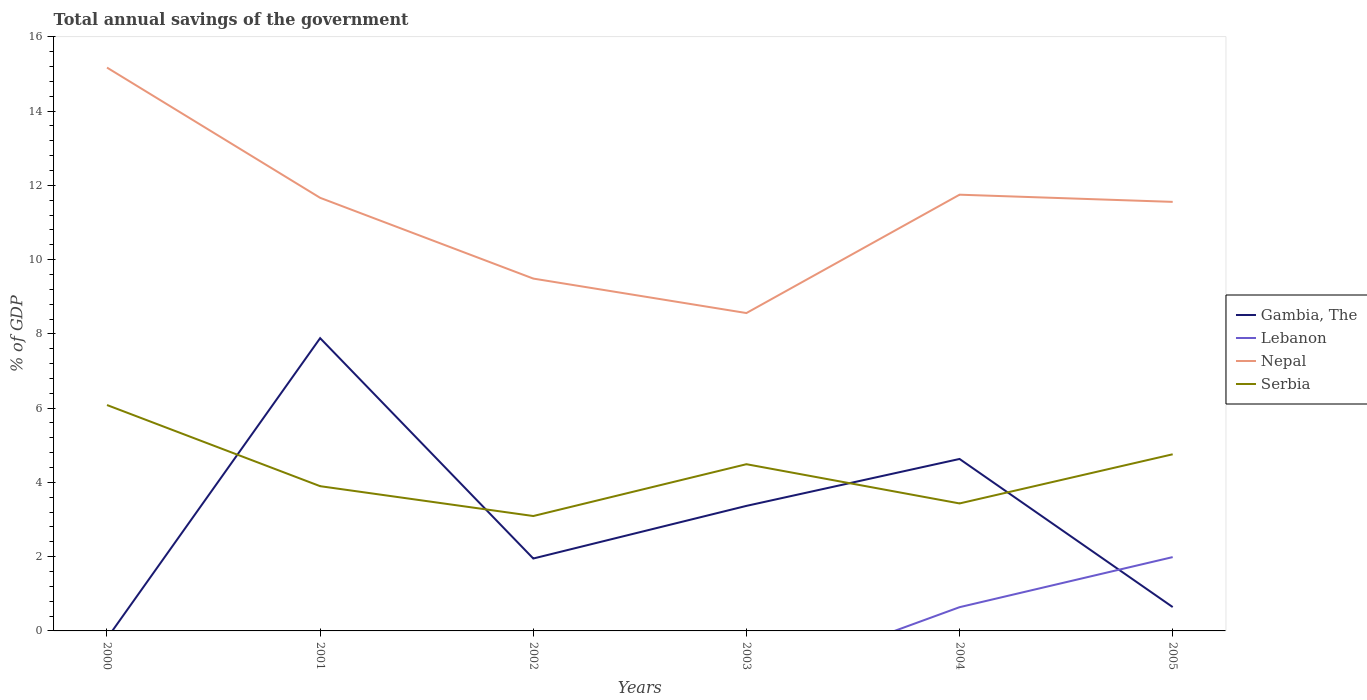Does the line corresponding to Nepal intersect with the line corresponding to Lebanon?
Give a very brief answer. No. Across all years, what is the maximum total annual savings of the government in Gambia, The?
Ensure brevity in your answer.  0. What is the total total annual savings of the government in Serbia in the graph?
Keep it short and to the point. -1.66. What is the difference between the highest and the second highest total annual savings of the government in Gambia, The?
Give a very brief answer. 7.89. What is the difference between the highest and the lowest total annual savings of the government in Gambia, The?
Keep it short and to the point. 3. Is the total annual savings of the government in Gambia, The strictly greater than the total annual savings of the government in Serbia over the years?
Your response must be concise. No. What is the difference between two consecutive major ticks on the Y-axis?
Offer a terse response. 2. Does the graph contain any zero values?
Offer a very short reply. Yes. Where does the legend appear in the graph?
Make the answer very short. Center right. How many legend labels are there?
Ensure brevity in your answer.  4. What is the title of the graph?
Give a very brief answer. Total annual savings of the government. Does "Aruba" appear as one of the legend labels in the graph?
Give a very brief answer. No. What is the label or title of the Y-axis?
Your answer should be very brief. % of GDP. What is the % of GDP of Gambia, The in 2000?
Ensure brevity in your answer.  0. What is the % of GDP of Nepal in 2000?
Your answer should be very brief. 15.17. What is the % of GDP in Serbia in 2000?
Keep it short and to the point. 6.08. What is the % of GDP in Gambia, The in 2001?
Offer a terse response. 7.89. What is the % of GDP in Lebanon in 2001?
Ensure brevity in your answer.  0. What is the % of GDP in Nepal in 2001?
Give a very brief answer. 11.66. What is the % of GDP in Serbia in 2001?
Ensure brevity in your answer.  3.9. What is the % of GDP in Gambia, The in 2002?
Offer a very short reply. 1.95. What is the % of GDP of Nepal in 2002?
Your answer should be compact. 9.49. What is the % of GDP in Serbia in 2002?
Your response must be concise. 3.09. What is the % of GDP in Gambia, The in 2003?
Give a very brief answer. 3.37. What is the % of GDP of Lebanon in 2003?
Ensure brevity in your answer.  0. What is the % of GDP of Nepal in 2003?
Make the answer very short. 8.56. What is the % of GDP of Serbia in 2003?
Your answer should be very brief. 4.49. What is the % of GDP of Gambia, The in 2004?
Provide a succinct answer. 4.63. What is the % of GDP in Lebanon in 2004?
Offer a terse response. 0.64. What is the % of GDP in Nepal in 2004?
Your answer should be very brief. 11.75. What is the % of GDP in Serbia in 2004?
Your response must be concise. 3.43. What is the % of GDP of Gambia, The in 2005?
Ensure brevity in your answer.  0.64. What is the % of GDP of Lebanon in 2005?
Keep it short and to the point. 1.99. What is the % of GDP in Nepal in 2005?
Your response must be concise. 11.56. What is the % of GDP of Serbia in 2005?
Offer a very short reply. 4.76. Across all years, what is the maximum % of GDP of Gambia, The?
Make the answer very short. 7.89. Across all years, what is the maximum % of GDP in Lebanon?
Give a very brief answer. 1.99. Across all years, what is the maximum % of GDP in Nepal?
Give a very brief answer. 15.17. Across all years, what is the maximum % of GDP of Serbia?
Your response must be concise. 6.08. Across all years, what is the minimum % of GDP in Gambia, The?
Make the answer very short. 0. Across all years, what is the minimum % of GDP of Nepal?
Offer a terse response. 8.56. Across all years, what is the minimum % of GDP in Serbia?
Give a very brief answer. 3.09. What is the total % of GDP in Gambia, The in the graph?
Give a very brief answer. 18.48. What is the total % of GDP of Lebanon in the graph?
Give a very brief answer. 2.63. What is the total % of GDP of Nepal in the graph?
Give a very brief answer. 68.19. What is the total % of GDP in Serbia in the graph?
Provide a short and direct response. 25.76. What is the difference between the % of GDP in Nepal in 2000 and that in 2001?
Your answer should be compact. 3.51. What is the difference between the % of GDP of Serbia in 2000 and that in 2001?
Ensure brevity in your answer.  2.19. What is the difference between the % of GDP in Nepal in 2000 and that in 2002?
Make the answer very short. 5.68. What is the difference between the % of GDP of Serbia in 2000 and that in 2002?
Keep it short and to the point. 2.99. What is the difference between the % of GDP of Nepal in 2000 and that in 2003?
Offer a very short reply. 6.61. What is the difference between the % of GDP of Serbia in 2000 and that in 2003?
Your response must be concise. 1.59. What is the difference between the % of GDP of Nepal in 2000 and that in 2004?
Keep it short and to the point. 3.42. What is the difference between the % of GDP in Serbia in 2000 and that in 2004?
Your answer should be very brief. 2.65. What is the difference between the % of GDP in Nepal in 2000 and that in 2005?
Offer a very short reply. 3.62. What is the difference between the % of GDP in Serbia in 2000 and that in 2005?
Keep it short and to the point. 1.33. What is the difference between the % of GDP of Gambia, The in 2001 and that in 2002?
Offer a very short reply. 5.93. What is the difference between the % of GDP of Nepal in 2001 and that in 2002?
Make the answer very short. 2.17. What is the difference between the % of GDP of Serbia in 2001 and that in 2002?
Your answer should be very brief. 0.8. What is the difference between the % of GDP in Gambia, The in 2001 and that in 2003?
Give a very brief answer. 4.52. What is the difference between the % of GDP of Nepal in 2001 and that in 2003?
Ensure brevity in your answer.  3.1. What is the difference between the % of GDP in Serbia in 2001 and that in 2003?
Your answer should be compact. -0.59. What is the difference between the % of GDP of Gambia, The in 2001 and that in 2004?
Keep it short and to the point. 3.25. What is the difference between the % of GDP of Nepal in 2001 and that in 2004?
Your response must be concise. -0.08. What is the difference between the % of GDP of Serbia in 2001 and that in 2004?
Make the answer very short. 0.47. What is the difference between the % of GDP of Gambia, The in 2001 and that in 2005?
Make the answer very short. 7.24. What is the difference between the % of GDP of Nepal in 2001 and that in 2005?
Your answer should be very brief. 0.11. What is the difference between the % of GDP of Serbia in 2001 and that in 2005?
Give a very brief answer. -0.86. What is the difference between the % of GDP in Gambia, The in 2002 and that in 2003?
Provide a short and direct response. -1.42. What is the difference between the % of GDP in Nepal in 2002 and that in 2003?
Ensure brevity in your answer.  0.93. What is the difference between the % of GDP of Serbia in 2002 and that in 2003?
Provide a succinct answer. -1.4. What is the difference between the % of GDP of Gambia, The in 2002 and that in 2004?
Ensure brevity in your answer.  -2.68. What is the difference between the % of GDP in Nepal in 2002 and that in 2004?
Your answer should be very brief. -2.26. What is the difference between the % of GDP in Serbia in 2002 and that in 2004?
Your answer should be very brief. -0.34. What is the difference between the % of GDP in Gambia, The in 2002 and that in 2005?
Make the answer very short. 1.31. What is the difference between the % of GDP of Nepal in 2002 and that in 2005?
Provide a short and direct response. -2.07. What is the difference between the % of GDP of Serbia in 2002 and that in 2005?
Offer a very short reply. -1.66. What is the difference between the % of GDP in Gambia, The in 2003 and that in 2004?
Offer a very short reply. -1.26. What is the difference between the % of GDP in Nepal in 2003 and that in 2004?
Keep it short and to the point. -3.19. What is the difference between the % of GDP in Serbia in 2003 and that in 2004?
Ensure brevity in your answer.  1.06. What is the difference between the % of GDP in Gambia, The in 2003 and that in 2005?
Provide a short and direct response. 2.73. What is the difference between the % of GDP in Nepal in 2003 and that in 2005?
Provide a short and direct response. -2.99. What is the difference between the % of GDP of Serbia in 2003 and that in 2005?
Ensure brevity in your answer.  -0.27. What is the difference between the % of GDP in Gambia, The in 2004 and that in 2005?
Your answer should be very brief. 3.99. What is the difference between the % of GDP in Lebanon in 2004 and that in 2005?
Your response must be concise. -1.35. What is the difference between the % of GDP of Nepal in 2004 and that in 2005?
Your answer should be compact. 0.19. What is the difference between the % of GDP in Serbia in 2004 and that in 2005?
Your answer should be compact. -1.32. What is the difference between the % of GDP of Nepal in 2000 and the % of GDP of Serbia in 2001?
Provide a short and direct response. 11.27. What is the difference between the % of GDP in Nepal in 2000 and the % of GDP in Serbia in 2002?
Offer a very short reply. 12.08. What is the difference between the % of GDP in Nepal in 2000 and the % of GDP in Serbia in 2003?
Offer a terse response. 10.68. What is the difference between the % of GDP of Nepal in 2000 and the % of GDP of Serbia in 2004?
Provide a short and direct response. 11.74. What is the difference between the % of GDP of Nepal in 2000 and the % of GDP of Serbia in 2005?
Ensure brevity in your answer.  10.41. What is the difference between the % of GDP of Gambia, The in 2001 and the % of GDP of Nepal in 2002?
Provide a short and direct response. -1.6. What is the difference between the % of GDP in Gambia, The in 2001 and the % of GDP in Serbia in 2002?
Keep it short and to the point. 4.79. What is the difference between the % of GDP of Nepal in 2001 and the % of GDP of Serbia in 2002?
Offer a terse response. 8.57. What is the difference between the % of GDP in Gambia, The in 2001 and the % of GDP in Nepal in 2003?
Offer a very short reply. -0.68. What is the difference between the % of GDP in Gambia, The in 2001 and the % of GDP in Serbia in 2003?
Make the answer very short. 3.39. What is the difference between the % of GDP of Nepal in 2001 and the % of GDP of Serbia in 2003?
Keep it short and to the point. 7.17. What is the difference between the % of GDP of Gambia, The in 2001 and the % of GDP of Lebanon in 2004?
Offer a terse response. 7.25. What is the difference between the % of GDP of Gambia, The in 2001 and the % of GDP of Nepal in 2004?
Ensure brevity in your answer.  -3.86. What is the difference between the % of GDP of Gambia, The in 2001 and the % of GDP of Serbia in 2004?
Make the answer very short. 4.45. What is the difference between the % of GDP of Nepal in 2001 and the % of GDP of Serbia in 2004?
Provide a succinct answer. 8.23. What is the difference between the % of GDP in Gambia, The in 2001 and the % of GDP in Lebanon in 2005?
Provide a succinct answer. 5.9. What is the difference between the % of GDP of Gambia, The in 2001 and the % of GDP of Nepal in 2005?
Make the answer very short. -3.67. What is the difference between the % of GDP of Gambia, The in 2001 and the % of GDP of Serbia in 2005?
Your answer should be very brief. 3.13. What is the difference between the % of GDP of Nepal in 2001 and the % of GDP of Serbia in 2005?
Make the answer very short. 6.91. What is the difference between the % of GDP of Gambia, The in 2002 and the % of GDP of Nepal in 2003?
Make the answer very short. -6.61. What is the difference between the % of GDP in Gambia, The in 2002 and the % of GDP in Serbia in 2003?
Provide a succinct answer. -2.54. What is the difference between the % of GDP in Nepal in 2002 and the % of GDP in Serbia in 2003?
Give a very brief answer. 5. What is the difference between the % of GDP of Gambia, The in 2002 and the % of GDP of Lebanon in 2004?
Your answer should be compact. 1.31. What is the difference between the % of GDP in Gambia, The in 2002 and the % of GDP in Nepal in 2004?
Your answer should be very brief. -9.8. What is the difference between the % of GDP in Gambia, The in 2002 and the % of GDP in Serbia in 2004?
Keep it short and to the point. -1.48. What is the difference between the % of GDP in Nepal in 2002 and the % of GDP in Serbia in 2004?
Give a very brief answer. 6.06. What is the difference between the % of GDP of Gambia, The in 2002 and the % of GDP of Lebanon in 2005?
Make the answer very short. -0.04. What is the difference between the % of GDP in Gambia, The in 2002 and the % of GDP in Nepal in 2005?
Ensure brevity in your answer.  -9.61. What is the difference between the % of GDP in Gambia, The in 2002 and the % of GDP in Serbia in 2005?
Give a very brief answer. -2.81. What is the difference between the % of GDP of Nepal in 2002 and the % of GDP of Serbia in 2005?
Your answer should be compact. 4.73. What is the difference between the % of GDP of Gambia, The in 2003 and the % of GDP of Lebanon in 2004?
Keep it short and to the point. 2.73. What is the difference between the % of GDP of Gambia, The in 2003 and the % of GDP of Nepal in 2004?
Provide a short and direct response. -8.38. What is the difference between the % of GDP in Gambia, The in 2003 and the % of GDP in Serbia in 2004?
Make the answer very short. -0.07. What is the difference between the % of GDP in Nepal in 2003 and the % of GDP in Serbia in 2004?
Ensure brevity in your answer.  5.13. What is the difference between the % of GDP of Gambia, The in 2003 and the % of GDP of Lebanon in 2005?
Offer a terse response. 1.38. What is the difference between the % of GDP of Gambia, The in 2003 and the % of GDP of Nepal in 2005?
Make the answer very short. -8.19. What is the difference between the % of GDP in Gambia, The in 2003 and the % of GDP in Serbia in 2005?
Provide a succinct answer. -1.39. What is the difference between the % of GDP in Nepal in 2003 and the % of GDP in Serbia in 2005?
Provide a succinct answer. 3.8. What is the difference between the % of GDP of Gambia, The in 2004 and the % of GDP of Lebanon in 2005?
Offer a terse response. 2.64. What is the difference between the % of GDP of Gambia, The in 2004 and the % of GDP of Nepal in 2005?
Make the answer very short. -6.92. What is the difference between the % of GDP in Gambia, The in 2004 and the % of GDP in Serbia in 2005?
Your answer should be very brief. -0.13. What is the difference between the % of GDP in Lebanon in 2004 and the % of GDP in Nepal in 2005?
Give a very brief answer. -10.92. What is the difference between the % of GDP in Lebanon in 2004 and the % of GDP in Serbia in 2005?
Ensure brevity in your answer.  -4.12. What is the difference between the % of GDP of Nepal in 2004 and the % of GDP of Serbia in 2005?
Keep it short and to the point. 6.99. What is the average % of GDP in Gambia, The per year?
Make the answer very short. 3.08. What is the average % of GDP in Lebanon per year?
Your answer should be compact. 0.44. What is the average % of GDP of Nepal per year?
Ensure brevity in your answer.  11.37. What is the average % of GDP in Serbia per year?
Offer a very short reply. 4.29. In the year 2000, what is the difference between the % of GDP of Nepal and % of GDP of Serbia?
Provide a succinct answer. 9.09. In the year 2001, what is the difference between the % of GDP of Gambia, The and % of GDP of Nepal?
Provide a succinct answer. -3.78. In the year 2001, what is the difference between the % of GDP in Gambia, The and % of GDP in Serbia?
Keep it short and to the point. 3.99. In the year 2001, what is the difference between the % of GDP in Nepal and % of GDP in Serbia?
Offer a terse response. 7.77. In the year 2002, what is the difference between the % of GDP of Gambia, The and % of GDP of Nepal?
Offer a very short reply. -7.54. In the year 2002, what is the difference between the % of GDP in Gambia, The and % of GDP in Serbia?
Your answer should be compact. -1.14. In the year 2002, what is the difference between the % of GDP in Nepal and % of GDP in Serbia?
Offer a terse response. 6.4. In the year 2003, what is the difference between the % of GDP in Gambia, The and % of GDP in Nepal?
Give a very brief answer. -5.19. In the year 2003, what is the difference between the % of GDP in Gambia, The and % of GDP in Serbia?
Your answer should be very brief. -1.12. In the year 2003, what is the difference between the % of GDP in Nepal and % of GDP in Serbia?
Ensure brevity in your answer.  4.07. In the year 2004, what is the difference between the % of GDP of Gambia, The and % of GDP of Lebanon?
Keep it short and to the point. 3.99. In the year 2004, what is the difference between the % of GDP in Gambia, The and % of GDP in Nepal?
Keep it short and to the point. -7.12. In the year 2004, what is the difference between the % of GDP in Gambia, The and % of GDP in Serbia?
Provide a succinct answer. 1.2. In the year 2004, what is the difference between the % of GDP of Lebanon and % of GDP of Nepal?
Offer a terse response. -11.11. In the year 2004, what is the difference between the % of GDP in Lebanon and % of GDP in Serbia?
Offer a very short reply. -2.79. In the year 2004, what is the difference between the % of GDP of Nepal and % of GDP of Serbia?
Your answer should be very brief. 8.32. In the year 2005, what is the difference between the % of GDP in Gambia, The and % of GDP in Lebanon?
Your response must be concise. -1.35. In the year 2005, what is the difference between the % of GDP in Gambia, The and % of GDP in Nepal?
Offer a very short reply. -10.91. In the year 2005, what is the difference between the % of GDP in Gambia, The and % of GDP in Serbia?
Provide a short and direct response. -4.12. In the year 2005, what is the difference between the % of GDP in Lebanon and % of GDP in Nepal?
Provide a short and direct response. -9.57. In the year 2005, what is the difference between the % of GDP of Lebanon and % of GDP of Serbia?
Provide a short and direct response. -2.77. In the year 2005, what is the difference between the % of GDP in Nepal and % of GDP in Serbia?
Your answer should be compact. 6.8. What is the ratio of the % of GDP in Nepal in 2000 to that in 2001?
Offer a terse response. 1.3. What is the ratio of the % of GDP in Serbia in 2000 to that in 2001?
Provide a succinct answer. 1.56. What is the ratio of the % of GDP in Nepal in 2000 to that in 2002?
Offer a very short reply. 1.6. What is the ratio of the % of GDP in Serbia in 2000 to that in 2002?
Provide a short and direct response. 1.97. What is the ratio of the % of GDP in Nepal in 2000 to that in 2003?
Make the answer very short. 1.77. What is the ratio of the % of GDP of Serbia in 2000 to that in 2003?
Your answer should be compact. 1.35. What is the ratio of the % of GDP in Nepal in 2000 to that in 2004?
Ensure brevity in your answer.  1.29. What is the ratio of the % of GDP in Serbia in 2000 to that in 2004?
Ensure brevity in your answer.  1.77. What is the ratio of the % of GDP in Nepal in 2000 to that in 2005?
Your response must be concise. 1.31. What is the ratio of the % of GDP in Serbia in 2000 to that in 2005?
Provide a short and direct response. 1.28. What is the ratio of the % of GDP in Gambia, The in 2001 to that in 2002?
Your response must be concise. 4.04. What is the ratio of the % of GDP in Nepal in 2001 to that in 2002?
Provide a succinct answer. 1.23. What is the ratio of the % of GDP in Serbia in 2001 to that in 2002?
Your answer should be very brief. 1.26. What is the ratio of the % of GDP in Gambia, The in 2001 to that in 2003?
Offer a terse response. 2.34. What is the ratio of the % of GDP in Nepal in 2001 to that in 2003?
Offer a terse response. 1.36. What is the ratio of the % of GDP in Serbia in 2001 to that in 2003?
Your answer should be compact. 0.87. What is the ratio of the % of GDP in Gambia, The in 2001 to that in 2004?
Provide a succinct answer. 1.7. What is the ratio of the % of GDP in Nepal in 2001 to that in 2004?
Give a very brief answer. 0.99. What is the ratio of the % of GDP in Serbia in 2001 to that in 2004?
Offer a very short reply. 1.14. What is the ratio of the % of GDP in Gambia, The in 2001 to that in 2005?
Provide a succinct answer. 12.27. What is the ratio of the % of GDP in Nepal in 2001 to that in 2005?
Offer a very short reply. 1.01. What is the ratio of the % of GDP of Serbia in 2001 to that in 2005?
Provide a succinct answer. 0.82. What is the ratio of the % of GDP in Gambia, The in 2002 to that in 2003?
Your answer should be very brief. 0.58. What is the ratio of the % of GDP in Nepal in 2002 to that in 2003?
Your answer should be very brief. 1.11. What is the ratio of the % of GDP in Serbia in 2002 to that in 2003?
Your answer should be very brief. 0.69. What is the ratio of the % of GDP in Gambia, The in 2002 to that in 2004?
Provide a succinct answer. 0.42. What is the ratio of the % of GDP of Nepal in 2002 to that in 2004?
Offer a very short reply. 0.81. What is the ratio of the % of GDP of Serbia in 2002 to that in 2004?
Offer a very short reply. 0.9. What is the ratio of the % of GDP of Gambia, The in 2002 to that in 2005?
Provide a short and direct response. 3.04. What is the ratio of the % of GDP in Nepal in 2002 to that in 2005?
Offer a very short reply. 0.82. What is the ratio of the % of GDP of Serbia in 2002 to that in 2005?
Offer a terse response. 0.65. What is the ratio of the % of GDP in Gambia, The in 2003 to that in 2004?
Provide a succinct answer. 0.73. What is the ratio of the % of GDP in Nepal in 2003 to that in 2004?
Offer a terse response. 0.73. What is the ratio of the % of GDP of Serbia in 2003 to that in 2004?
Your answer should be compact. 1.31. What is the ratio of the % of GDP of Gambia, The in 2003 to that in 2005?
Your response must be concise. 5.24. What is the ratio of the % of GDP of Nepal in 2003 to that in 2005?
Keep it short and to the point. 0.74. What is the ratio of the % of GDP in Serbia in 2003 to that in 2005?
Keep it short and to the point. 0.94. What is the ratio of the % of GDP in Gambia, The in 2004 to that in 2005?
Your answer should be very brief. 7.21. What is the ratio of the % of GDP in Lebanon in 2004 to that in 2005?
Your response must be concise. 0.32. What is the ratio of the % of GDP in Nepal in 2004 to that in 2005?
Give a very brief answer. 1.02. What is the ratio of the % of GDP in Serbia in 2004 to that in 2005?
Give a very brief answer. 0.72. What is the difference between the highest and the second highest % of GDP of Gambia, The?
Ensure brevity in your answer.  3.25. What is the difference between the highest and the second highest % of GDP of Nepal?
Ensure brevity in your answer.  3.42. What is the difference between the highest and the second highest % of GDP in Serbia?
Your response must be concise. 1.33. What is the difference between the highest and the lowest % of GDP in Gambia, The?
Provide a short and direct response. 7.89. What is the difference between the highest and the lowest % of GDP of Lebanon?
Provide a short and direct response. 1.99. What is the difference between the highest and the lowest % of GDP in Nepal?
Your answer should be very brief. 6.61. What is the difference between the highest and the lowest % of GDP in Serbia?
Give a very brief answer. 2.99. 